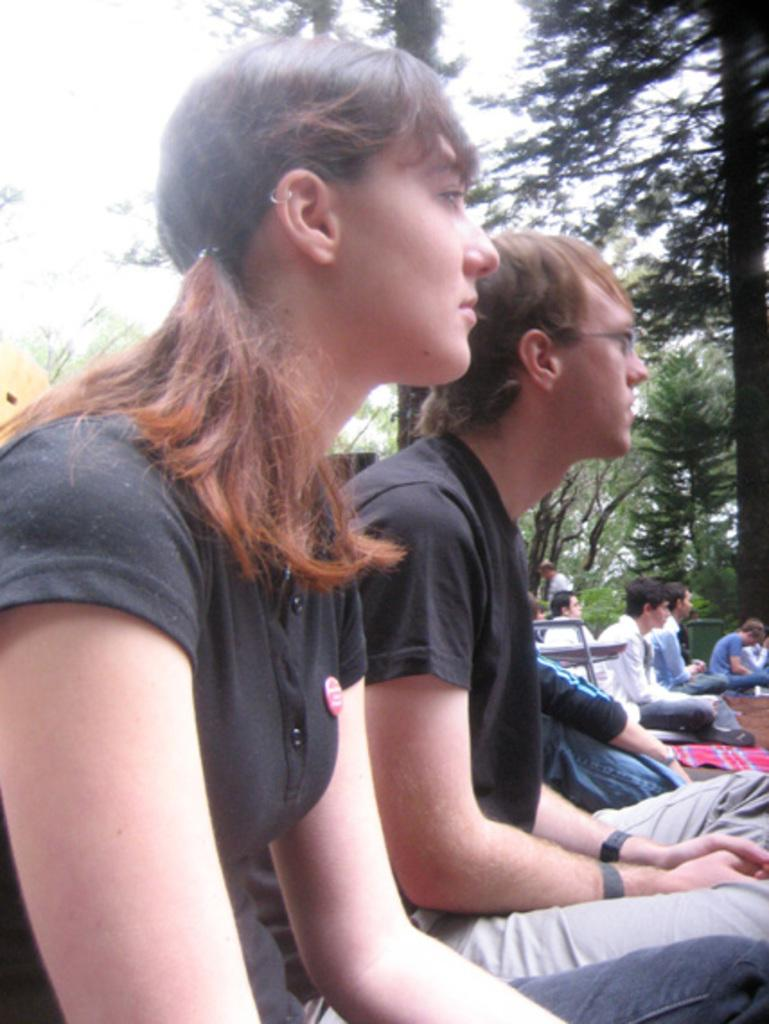What is the main subject of the image? The main subject of the image is a group of people sitting. Can you describe the seating arrangement in the image? There is a chair in the image, and it is likely that the group of people is sitting on it. What can be seen in the background of the image? Trees are visible in the background of the image. What type of paste is being used by the people in the image? There is no paste present in the image; it features a group of people sitting. What kind of pancake can be seen on the table in the image? There is no table or pancake present in the image. 